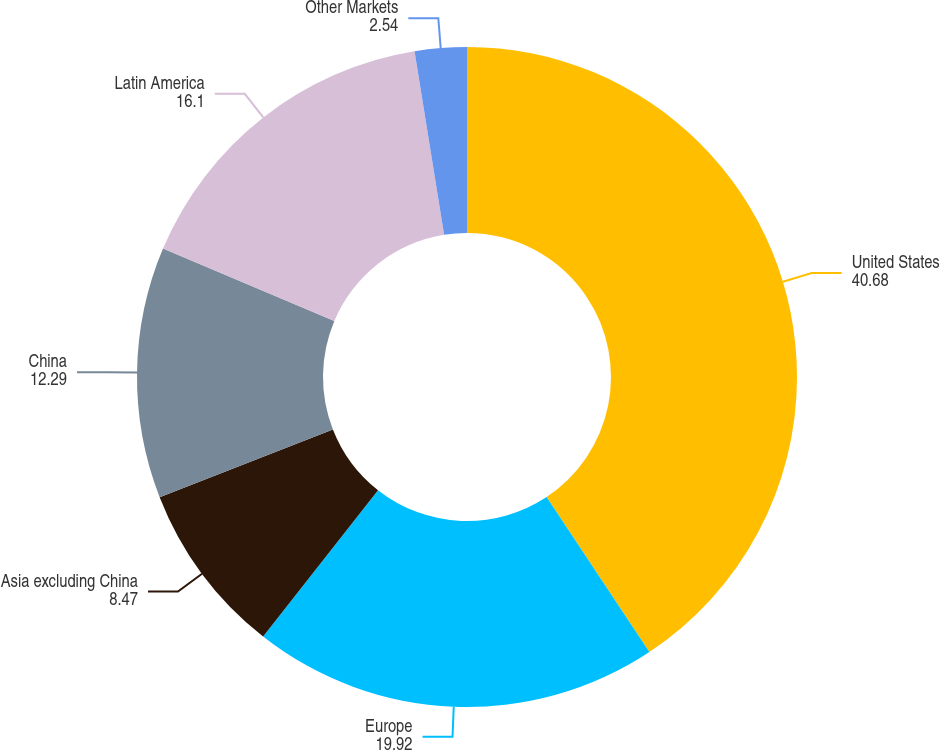Convert chart to OTSL. <chart><loc_0><loc_0><loc_500><loc_500><pie_chart><fcel>United States<fcel>Europe<fcel>Asia excluding China<fcel>China<fcel>Latin America<fcel>Other Markets<nl><fcel>40.68%<fcel>19.92%<fcel>8.47%<fcel>12.29%<fcel>16.1%<fcel>2.54%<nl></chart> 